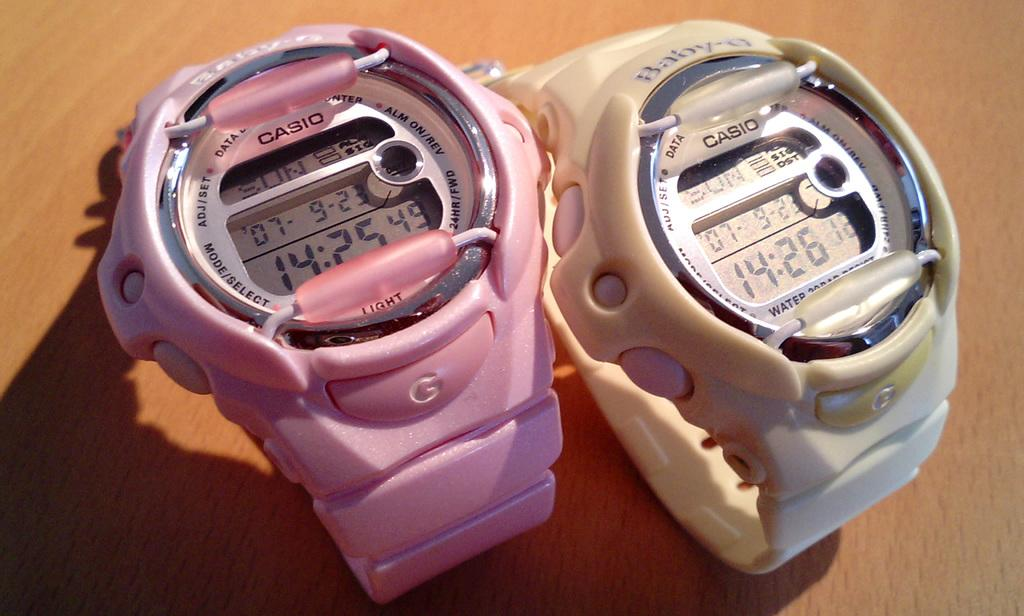<image>
Create a compact narrative representing the image presented. A pink and white Casio G digital watches next to each other ona table top. 